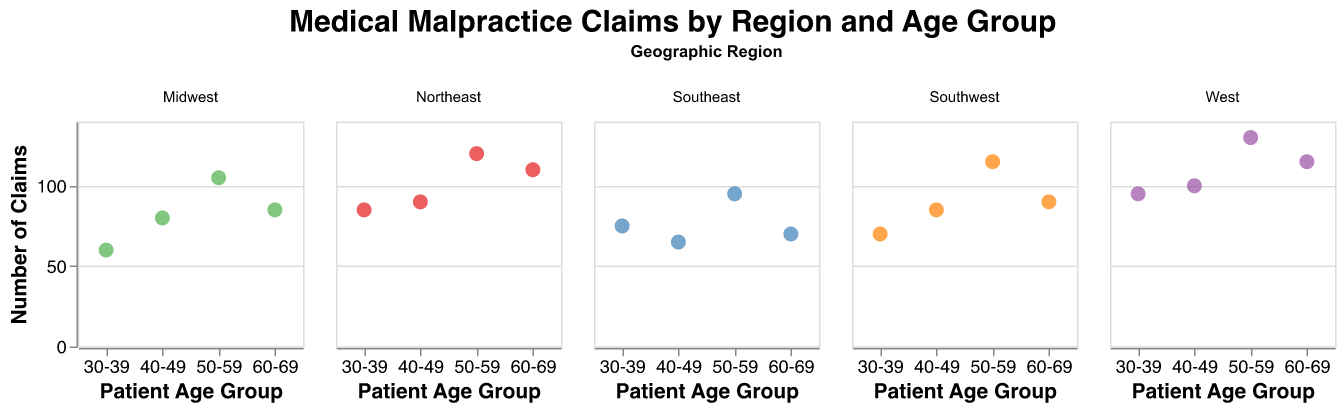What is the title of the figure? The title of the figure is located at the top and clearly states the main topic of the plot.
Answer: Medical Malpractice Claims by Region and Age Group In which geographic region is the highest number of claims for the 50-59 age group? To find the highest number of claims for the 50-59 age group, look at the circles representing this age group in each subplot and compare their y-axis values. The highest y-axis value for this age group is in the West region.
Answer: West What is the color used for the Midwest region? Each geographic region is represented by a different color. The color of the dots in the Midwest region indicates its assigned color.
Answer: Green Which age group in the Northeast has the least number of claims? In the Northeast facet, identify the circle with the lowest position on the y-axis, which corresponds to the lowest number of claims. This circle represents the 30-39 age group.
Answer: 30-39 How many claims are there for the 60-69 age group in the Southwest region? Locate the circle in the Southwest region facet that corresponds to the 60-69 age group and refer to its tooltip to find the exact number of claims, which is also indicated by its y-axis position.
Answer: 90 Compare the number of claims for the 40-49 age group between the Southeast and Southwest regions. Which region has more claims? Identify the points for the 40-49 age group in both the Southeast and Southwest regions. Comparing their positions on the y-axis, the Southwest region has more claims.
Answer: Southwest What is the average number of claims for all age groups in the Midwest region? To find the average, sum the number of claims for all age groups in the Midwest (60, 80, 105, 85) and divide by the number of groups (4). (60 + 80 + 105 + 85) / 4 = 82.5
Answer: 82.5 Which age group in the West region has the highest number of claims? In the West region facet, identify the circle with the highest position on the y-axis, representing the greatest number of claims. This corresponds to the 50-59 age group.
Answer: 50-59 What is the range of claims in the 50-59 age group across all regions? Identify the number of claims for the 50-59 age group in each region (Northeast: 120, Southeast: 95, Midwest: 105, West: 130, Southwest: 115) and find the difference between the highest (130) and lowest (95). (130-95) = 35
Answer: 35 